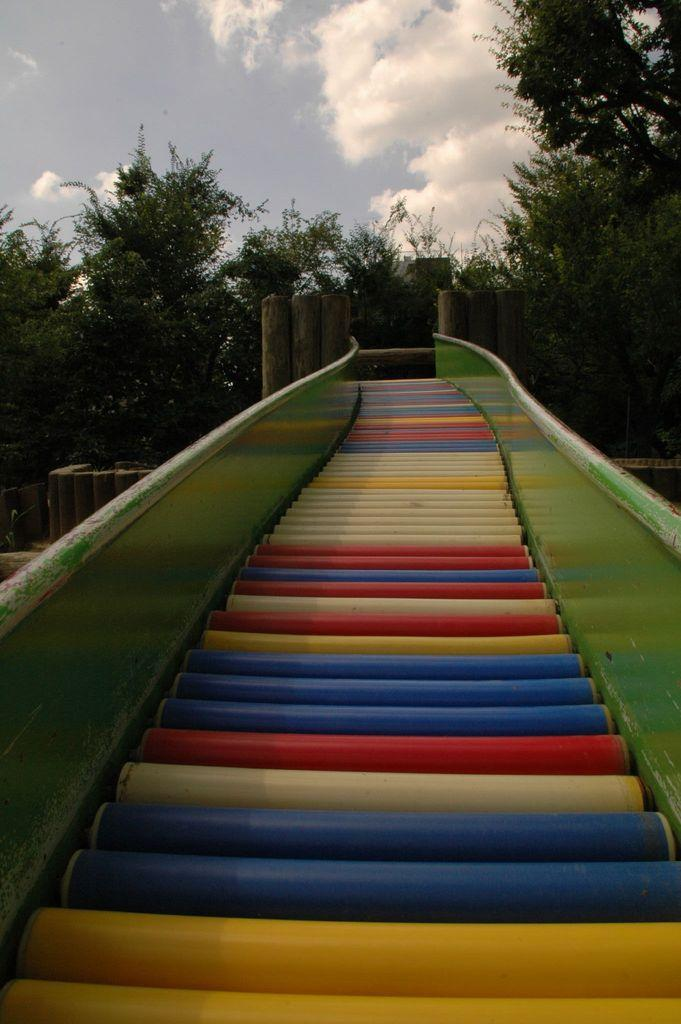What is the main structure in the center of the image? There is a bridge in the center of the image. What can be seen in the background of the image? There are trees and the sky visible in the background of the image. What is the condition of the sky in the image? Clouds are present in the sky in the image. How does the head of the person in the image look like? There is no person present in the image, only a bridge, trees, and the sky. What type of earthquake can be seen in the image? There is no earthquake present in the image; it features a bridge, trees, and the sky. 